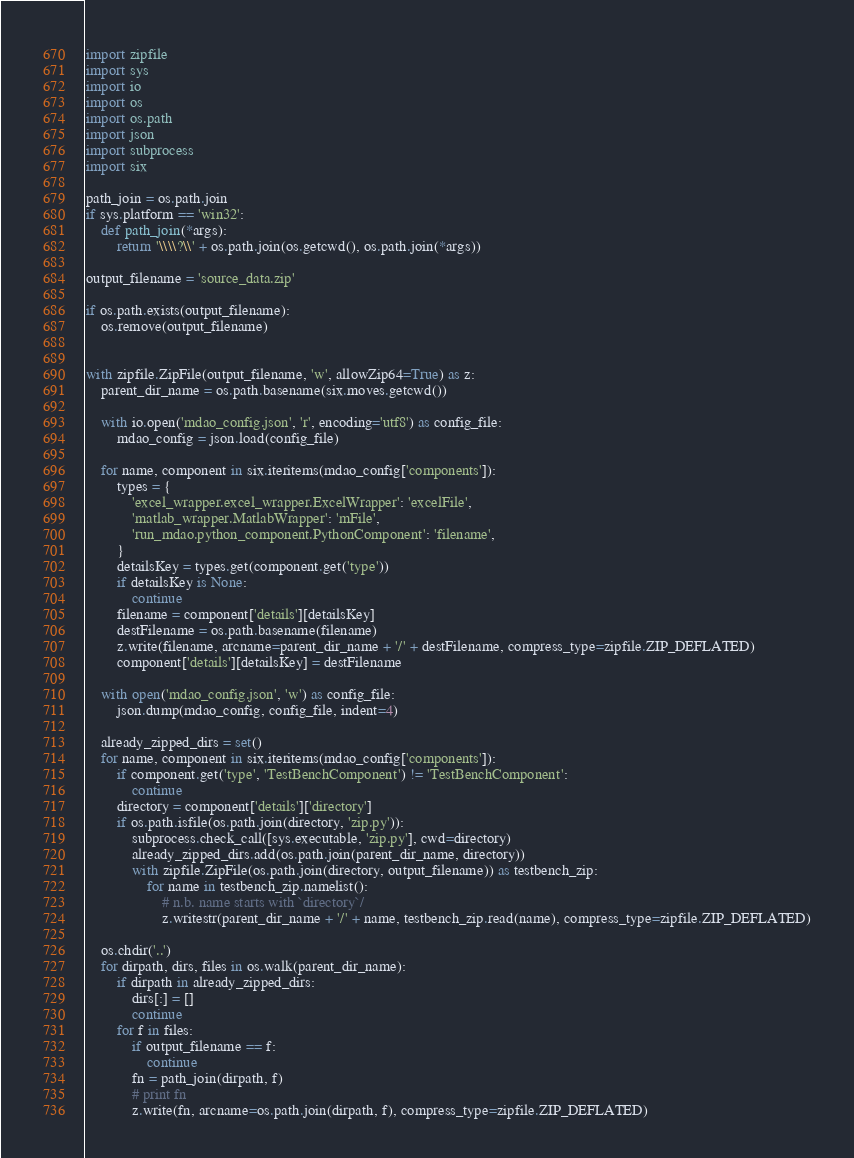Convert code to text. <code><loc_0><loc_0><loc_500><loc_500><_Python_>import zipfile
import sys
import io
import os
import os.path
import json
import subprocess
import six

path_join = os.path.join
if sys.platform == 'win32':
    def path_join(*args):
        return '\\\\?\\' + os.path.join(os.getcwd(), os.path.join(*args))

output_filename = 'source_data.zip'

if os.path.exists(output_filename):
    os.remove(output_filename)


with zipfile.ZipFile(output_filename, 'w', allowZip64=True) as z:
    parent_dir_name = os.path.basename(six.moves.getcwd())

    with io.open('mdao_config.json', 'r', encoding='utf8') as config_file:
        mdao_config = json.load(config_file)

    for name, component in six.iteritems(mdao_config['components']):
        types = {
            'excel_wrapper.excel_wrapper.ExcelWrapper': 'excelFile',
            'matlab_wrapper.MatlabWrapper': 'mFile',
            'run_mdao.python_component.PythonComponent': 'filename',
        }
        detailsKey = types.get(component.get('type'))
        if detailsKey is None:
            continue
        filename = component['details'][detailsKey]
        destFilename = os.path.basename(filename)
        z.write(filename, arcname=parent_dir_name + '/' + destFilename, compress_type=zipfile.ZIP_DEFLATED)
        component['details'][detailsKey] = destFilename

    with open('mdao_config.json', 'w') as config_file:
        json.dump(mdao_config, config_file, indent=4)

    already_zipped_dirs = set()
    for name, component in six.iteritems(mdao_config['components']):
        if component.get('type', 'TestBenchComponent') != 'TestBenchComponent':
            continue
        directory = component['details']['directory']
        if os.path.isfile(os.path.join(directory, 'zip.py')):
            subprocess.check_call([sys.executable, 'zip.py'], cwd=directory)
            already_zipped_dirs.add(os.path.join(parent_dir_name, directory))
            with zipfile.ZipFile(os.path.join(directory, output_filename)) as testbench_zip:
                for name in testbench_zip.namelist():
                    # n.b. name starts with `directory`/
                    z.writestr(parent_dir_name + '/' + name, testbench_zip.read(name), compress_type=zipfile.ZIP_DEFLATED)

    os.chdir('..')
    for dirpath, dirs, files in os.walk(parent_dir_name):
        if dirpath in already_zipped_dirs:
            dirs[:] = []
            continue
        for f in files:
            if output_filename == f:
                continue
            fn = path_join(dirpath, f)
            # print fn
            z.write(fn, arcname=os.path.join(dirpath, f), compress_type=zipfile.ZIP_DEFLATED)
</code> 